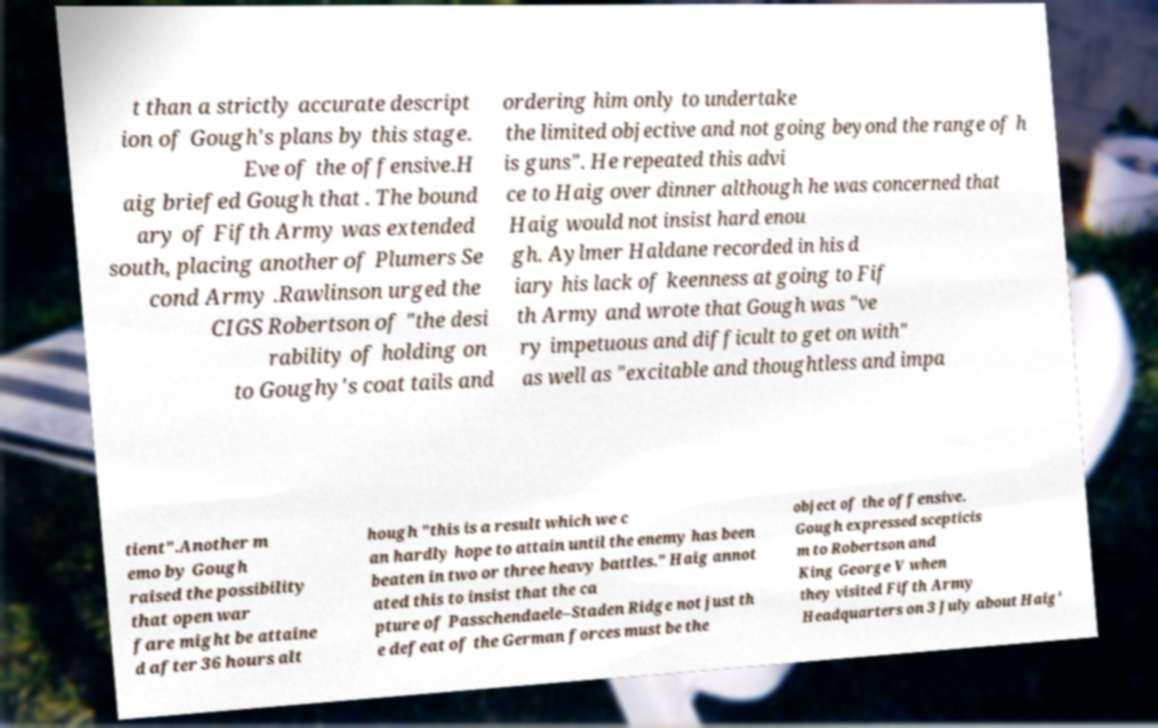Can you accurately transcribe the text from the provided image for me? t than a strictly accurate descript ion of Gough's plans by this stage. Eve of the offensive.H aig briefed Gough that . The bound ary of Fifth Army was extended south, placing another of Plumers Se cond Army .Rawlinson urged the CIGS Robertson of "the desi rability of holding on to Goughy's coat tails and ordering him only to undertake the limited objective and not going beyond the range of h is guns". He repeated this advi ce to Haig over dinner although he was concerned that Haig would not insist hard enou gh. Aylmer Haldane recorded in his d iary his lack of keenness at going to Fif th Army and wrote that Gough was "ve ry impetuous and difficult to get on with" as well as "excitable and thoughtless and impa tient".Another m emo by Gough raised the possibility that open war fare might be attaine d after 36 hours alt hough "this is a result which we c an hardly hope to attain until the enemy has been beaten in two or three heavy battles." Haig annot ated this to insist that the ca pture of Passchendaele–Staden Ridge not just th e defeat of the German forces must be the object of the offensive. Gough expressed scepticis m to Robertson and King George V when they visited Fifth Army Headquarters on 3 July about Haig' 